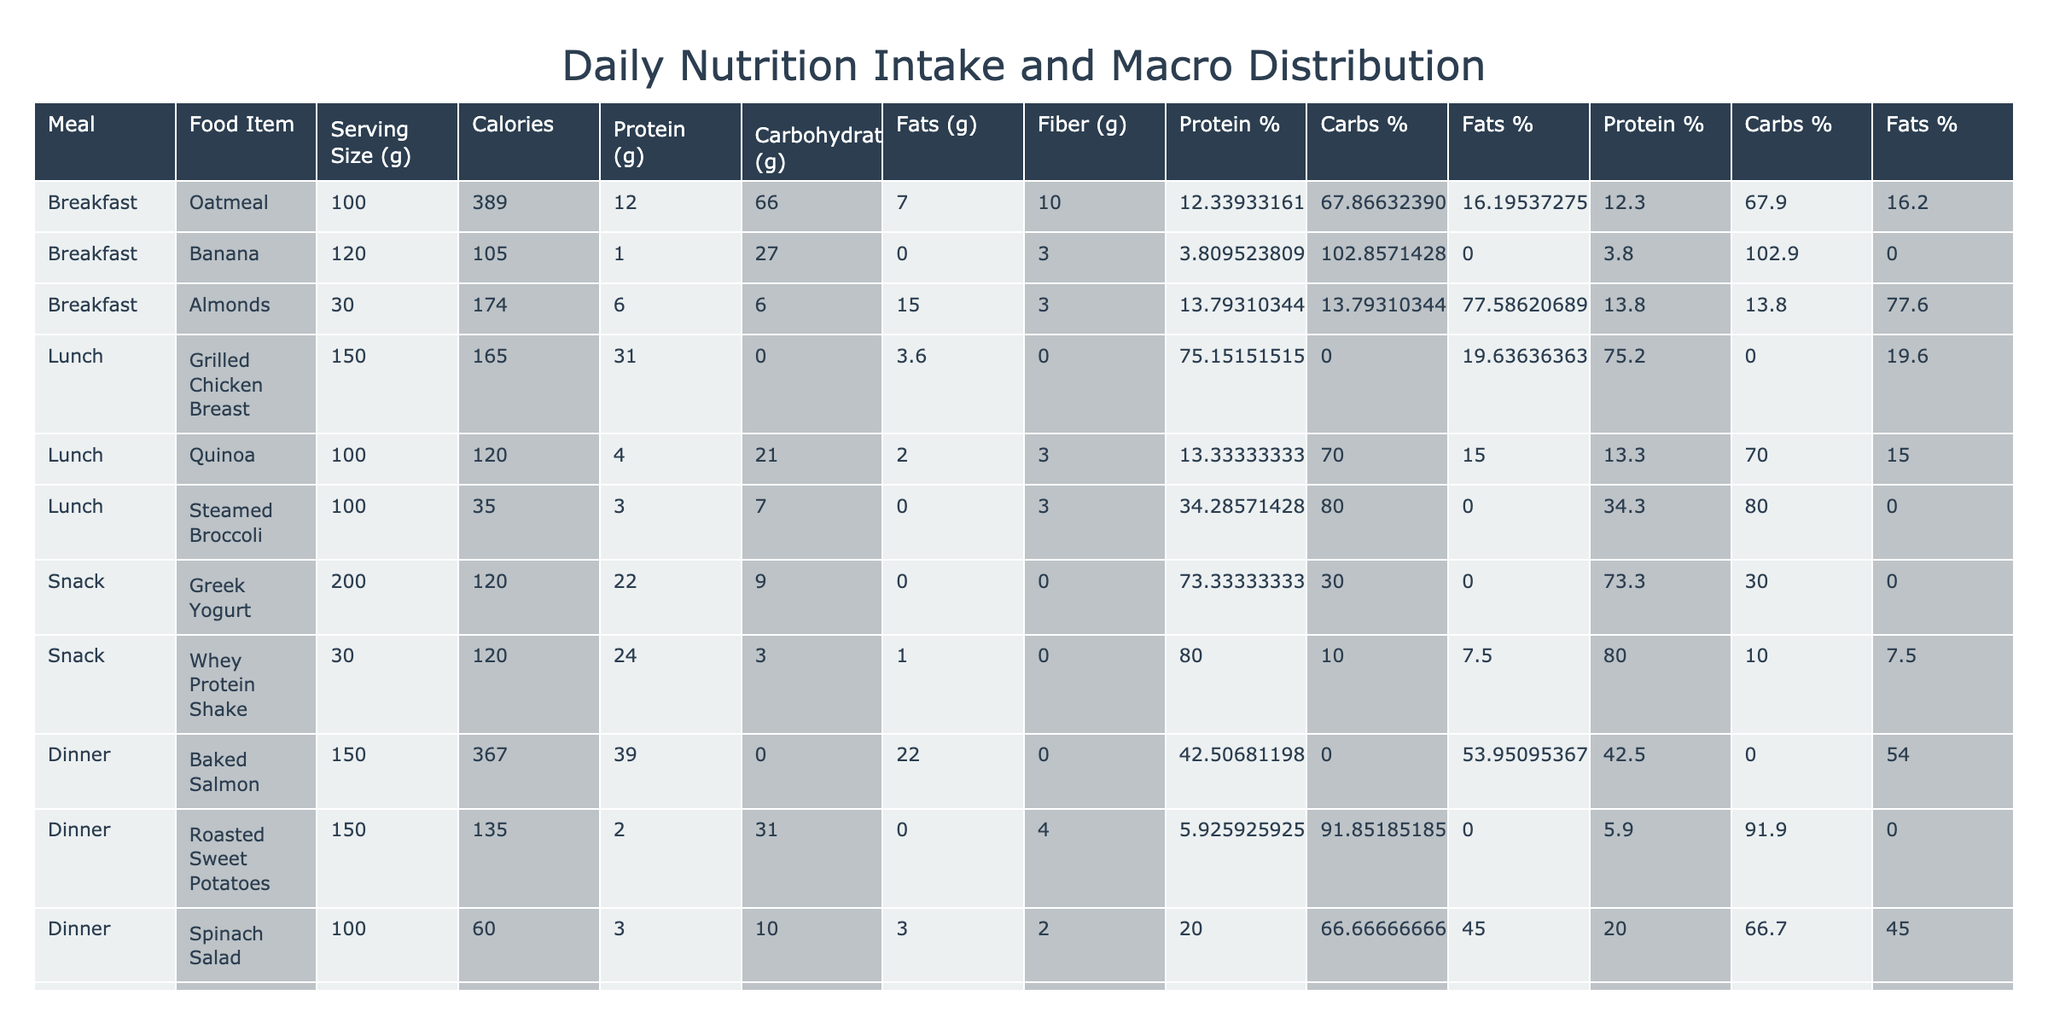What is the total calorie intake for the day? To find the total calorie intake, we need to sum the 'Calories' column in the table. Adding all values gives us 389 + 105 + 174 + 165 + 120 + 35 + 120 + 120 + 367 + 135 + 60 = 1,390 calories.
Answer: 1,390 calories How much protein is present in the lunch meal? The lunch meal consists of three items: Grilled Chicken Breast (31 g), Quinoa (4 g), and Steamed Broccoli (3 g). Adding these values gives us 31 + 4 + 3 = 38 g of protein.
Answer: 38 g What is the carbohydrate percentage of the total daily intake? First, we find the total carbohydrates by summing the 'Carbohydrates (g)' column: 66 + 27 + 6 + 0 + 21 + 7 + 9 + 3 + 0 + 31 + 10 = 280 g. Now, using total calories (1,390), the carbohydrate percentage is calculated as (280 g * 4) / 1390 x 100 = 80.6%.
Answer: 80.6% Is the total fat intake greater than the total fiber intake for the day? Total fats are 7 + 15 + 3.6 + 2 + 0 + 0 + 22 + 0 + 0 + 0 + 3 = 53.6 g and total fiber is 10 + 3 + 3 + 0 + 3 + 0 + 0 + 1 + 0 + 4 + 2 = 26 g. Since 53.6 g is greater than 26 g, the statement is true.
Answer: Yes What is the average protein content from breakfast foods? Breakfast has three items: Oatmeal (12 g), Banana (1 g), and Almonds (6 g). The sum of protein is 12 + 1 + 6 = 19 g. There are 3 breakfast items, so the average protein is 19 g / 3 = 6.33 g.
Answer: 6.33 g If I consumed the Baked Salmon for dinner, how many calories are coming specifically from fat? The Baked Salmon has 367 calories and 22 g of fat. Each gram of fat contributes 9 calories, so the total calories from fat are 22 g * 9 = 198 calories.
Answer: 198 calories Which meal has the highest protein content? By looking at the protein content for each meal: Breakfast (19 g), Lunch (38 g), Snack (46 g), and Dinner (44 g). The lunch meal has 38 g, while the snack has the highest at 46 g.
Answer: Snack What are the total grams of fiber from all meals? The total fiber intake is the sum of the 'Fiber (g)' column: 10 + 3 + 3 + 0 + 3 + 0 + 0 + 1 + 0 + 4 + 2 = 26 g.
Answer: 26 g Is the protein content of the Greek Yogurt higher than that of the Almonds? Greek Yogurt contains 22 g of protein while Almonds contain 6 g of protein. Comparing the two values, 22 g is greater than 6 g.
Answer: Yes What is the total serving size in grams for all measurable items? The total serving size is the sum of the 'Serving Size (g)' column: 100 + 120 + 30 + 150 + 100 + 100 + 200 + 30 + 150 + 150 + 100 = 1,330 g.
Answer: 1,330 g 